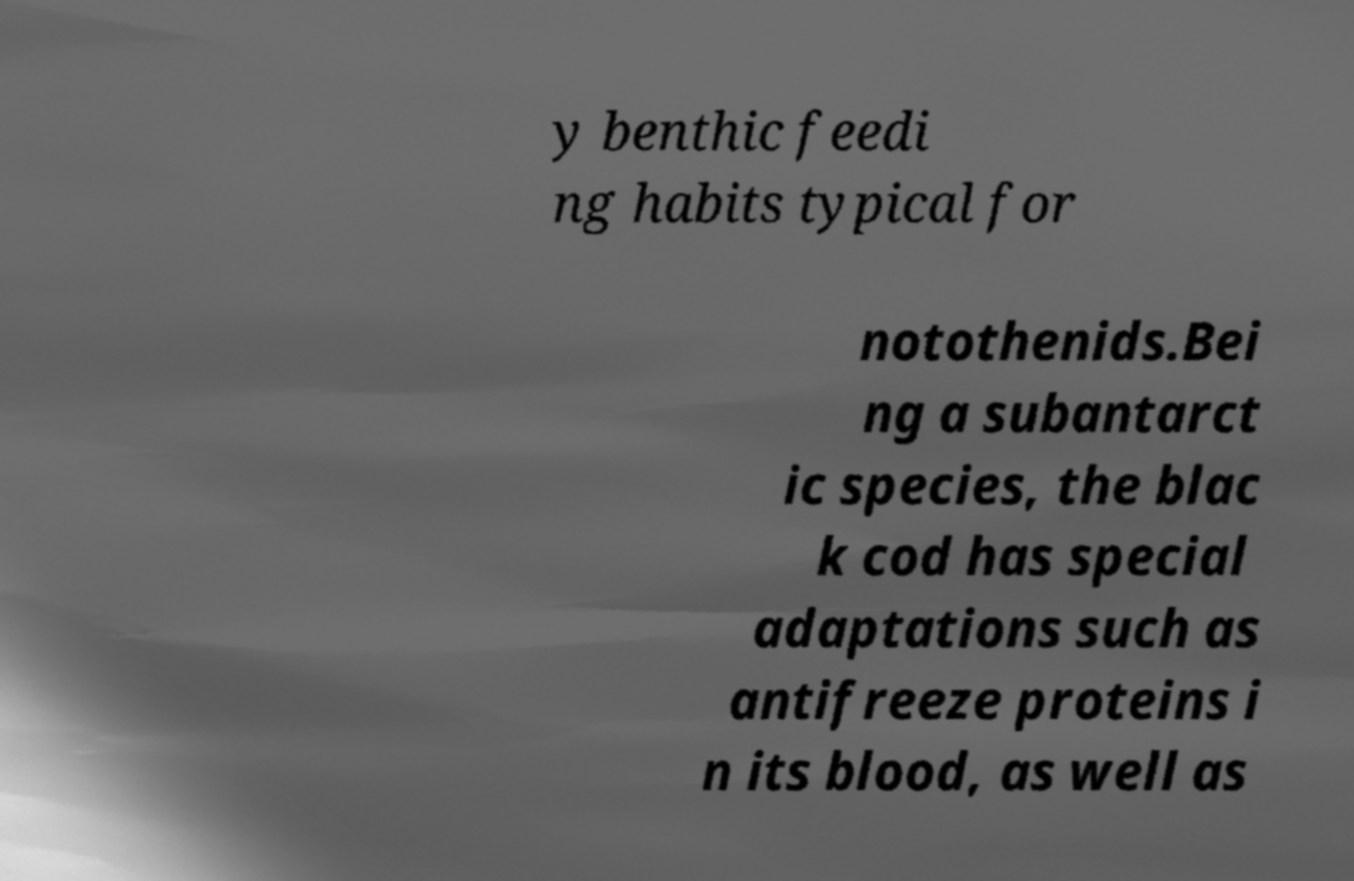Can you read and provide the text displayed in the image?This photo seems to have some interesting text. Can you extract and type it out for me? y benthic feedi ng habits typical for notothenids.Bei ng a subantarct ic species, the blac k cod has special adaptations such as antifreeze proteins i n its blood, as well as 